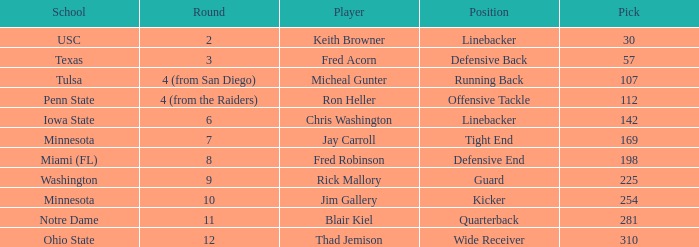What is the total pick number from round 2? 1.0. 